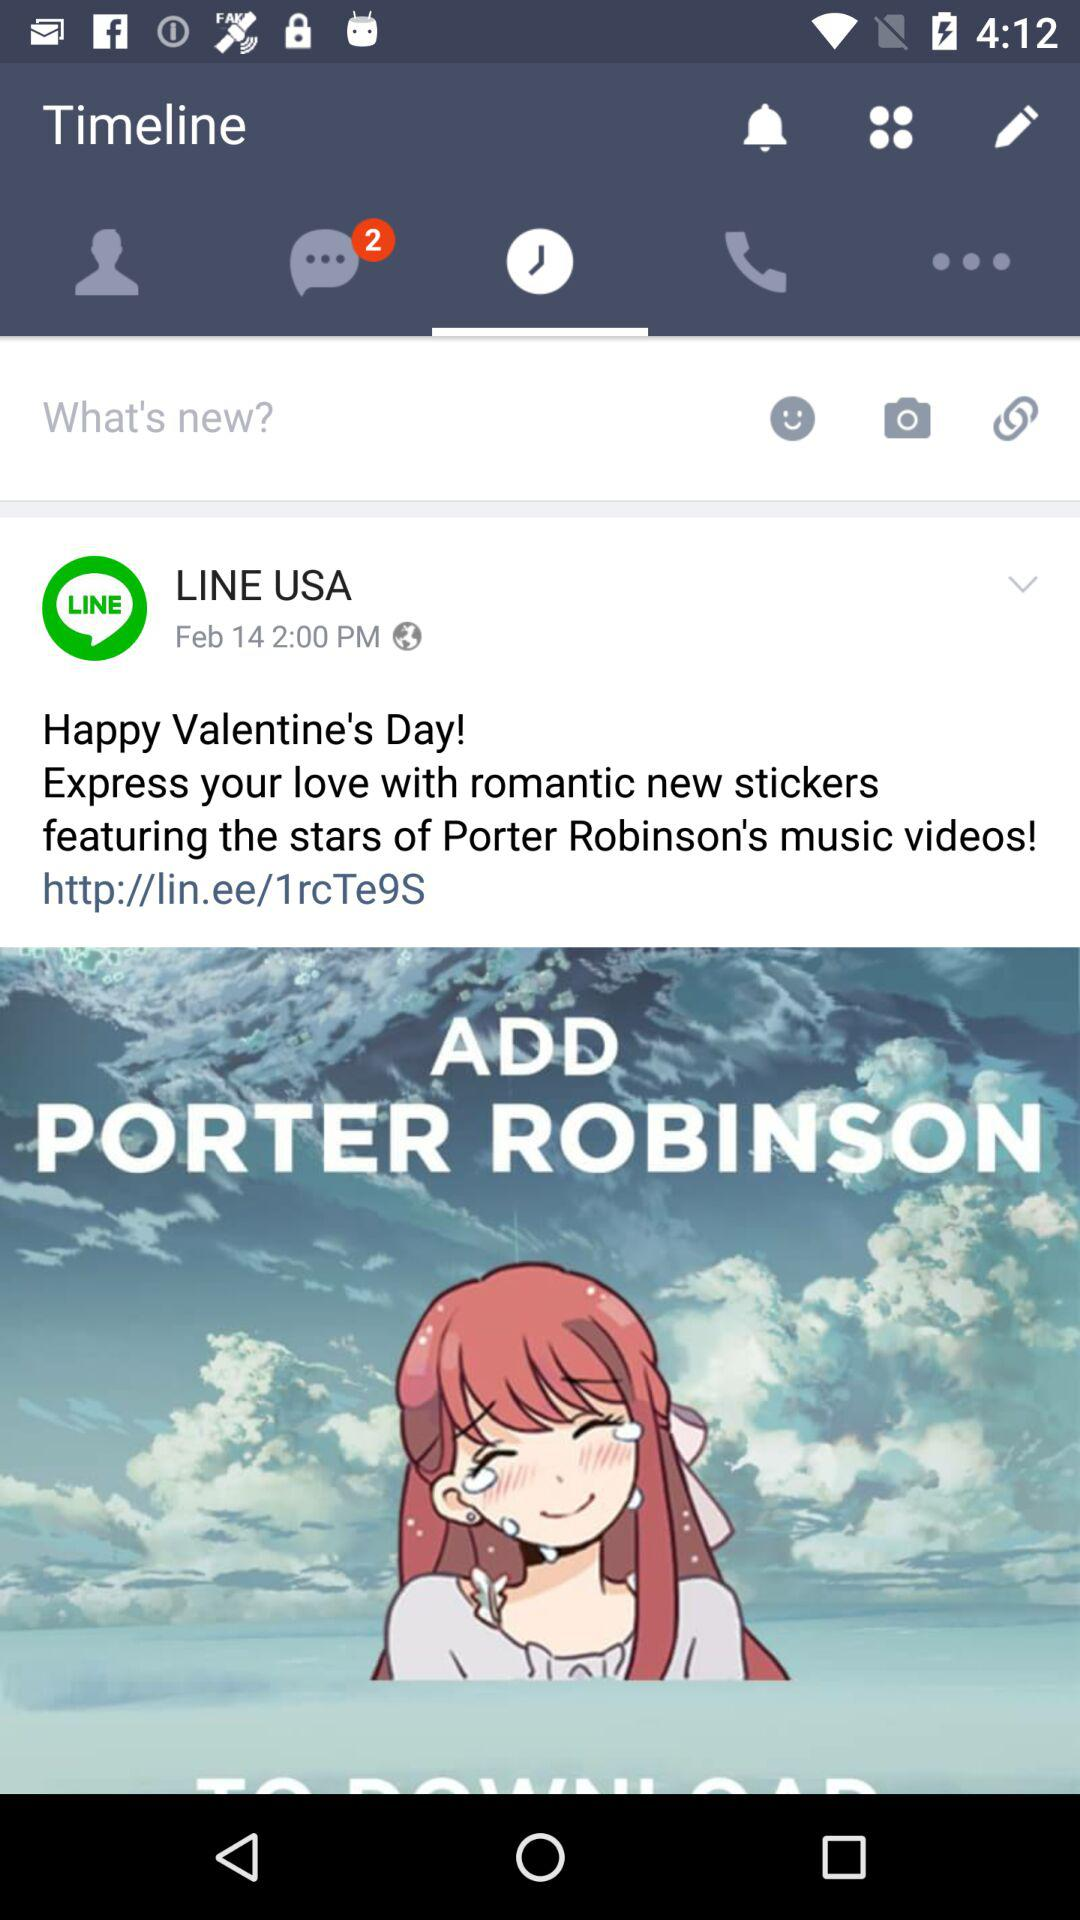What's the hyperlink address in the post? The hyperlink address in the post is http://lin.ee/1rcTe9S. 